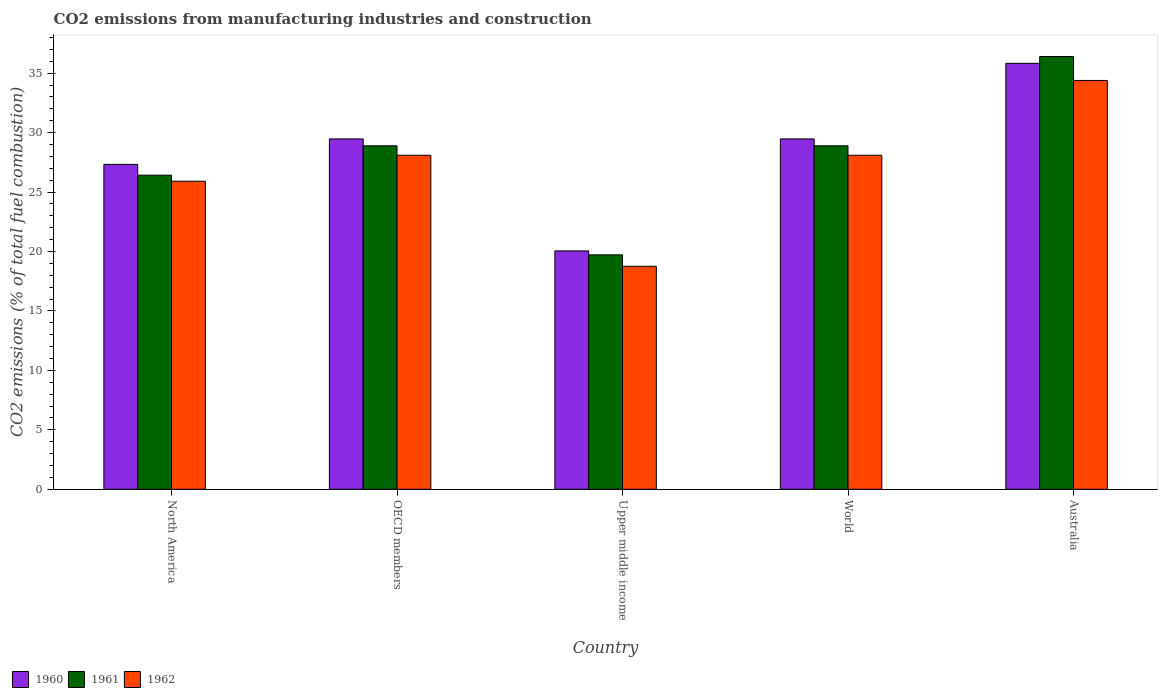How many different coloured bars are there?
Keep it short and to the point. 3. How many bars are there on the 2nd tick from the left?
Keep it short and to the point. 3. How many bars are there on the 2nd tick from the right?
Provide a succinct answer. 3. What is the label of the 3rd group of bars from the left?
Ensure brevity in your answer.  Upper middle income. What is the amount of CO2 emitted in 1961 in World?
Offer a terse response. 28.89. Across all countries, what is the maximum amount of CO2 emitted in 1961?
Your answer should be compact. 36.4. Across all countries, what is the minimum amount of CO2 emitted in 1960?
Your answer should be very brief. 20.05. In which country was the amount of CO2 emitted in 1962 maximum?
Your answer should be very brief. Australia. In which country was the amount of CO2 emitted in 1961 minimum?
Make the answer very short. Upper middle income. What is the total amount of CO2 emitted in 1962 in the graph?
Offer a very short reply. 135.24. What is the difference between the amount of CO2 emitted in 1962 in Upper middle income and that in World?
Provide a succinct answer. -9.34. What is the difference between the amount of CO2 emitted in 1960 in Australia and the amount of CO2 emitted in 1962 in Upper middle income?
Ensure brevity in your answer.  17.07. What is the average amount of CO2 emitted in 1960 per country?
Keep it short and to the point. 28.43. What is the difference between the amount of CO2 emitted of/in 1961 and amount of CO2 emitted of/in 1962 in Upper middle income?
Make the answer very short. 0.96. What is the ratio of the amount of CO2 emitted in 1960 in North America to that in Upper middle income?
Ensure brevity in your answer.  1.36. Is the amount of CO2 emitted in 1960 in OECD members less than that in World?
Ensure brevity in your answer.  No. Is the difference between the amount of CO2 emitted in 1961 in Australia and OECD members greater than the difference between the amount of CO2 emitted in 1962 in Australia and OECD members?
Offer a terse response. Yes. What is the difference between the highest and the second highest amount of CO2 emitted in 1961?
Provide a succinct answer. 7.51. What is the difference between the highest and the lowest amount of CO2 emitted in 1962?
Your response must be concise. 15.63. Are all the bars in the graph horizontal?
Offer a terse response. No. How many countries are there in the graph?
Make the answer very short. 5. Where does the legend appear in the graph?
Provide a short and direct response. Bottom left. What is the title of the graph?
Offer a terse response. CO2 emissions from manufacturing industries and construction. What is the label or title of the Y-axis?
Give a very brief answer. CO2 emissions (% of total fuel combustion). What is the CO2 emissions (% of total fuel combustion) of 1960 in North America?
Give a very brief answer. 27.33. What is the CO2 emissions (% of total fuel combustion) of 1961 in North America?
Your answer should be very brief. 26.42. What is the CO2 emissions (% of total fuel combustion) in 1962 in North America?
Keep it short and to the point. 25.91. What is the CO2 emissions (% of total fuel combustion) of 1960 in OECD members?
Offer a very short reply. 29.47. What is the CO2 emissions (% of total fuel combustion) of 1961 in OECD members?
Your answer should be compact. 28.89. What is the CO2 emissions (% of total fuel combustion) of 1962 in OECD members?
Provide a short and direct response. 28.09. What is the CO2 emissions (% of total fuel combustion) in 1960 in Upper middle income?
Provide a short and direct response. 20.05. What is the CO2 emissions (% of total fuel combustion) of 1961 in Upper middle income?
Keep it short and to the point. 19.72. What is the CO2 emissions (% of total fuel combustion) in 1962 in Upper middle income?
Give a very brief answer. 18.76. What is the CO2 emissions (% of total fuel combustion) of 1960 in World?
Offer a terse response. 29.47. What is the CO2 emissions (% of total fuel combustion) of 1961 in World?
Keep it short and to the point. 28.89. What is the CO2 emissions (% of total fuel combustion) in 1962 in World?
Offer a very short reply. 28.09. What is the CO2 emissions (% of total fuel combustion) of 1960 in Australia?
Your response must be concise. 35.83. What is the CO2 emissions (% of total fuel combustion) of 1961 in Australia?
Keep it short and to the point. 36.4. What is the CO2 emissions (% of total fuel combustion) in 1962 in Australia?
Ensure brevity in your answer.  34.39. Across all countries, what is the maximum CO2 emissions (% of total fuel combustion) in 1960?
Your response must be concise. 35.83. Across all countries, what is the maximum CO2 emissions (% of total fuel combustion) of 1961?
Your answer should be compact. 36.4. Across all countries, what is the maximum CO2 emissions (% of total fuel combustion) of 1962?
Make the answer very short. 34.39. Across all countries, what is the minimum CO2 emissions (% of total fuel combustion) in 1960?
Provide a succinct answer. 20.05. Across all countries, what is the minimum CO2 emissions (% of total fuel combustion) of 1961?
Give a very brief answer. 19.72. Across all countries, what is the minimum CO2 emissions (% of total fuel combustion) in 1962?
Your answer should be compact. 18.76. What is the total CO2 emissions (% of total fuel combustion) in 1960 in the graph?
Offer a very short reply. 142.14. What is the total CO2 emissions (% of total fuel combustion) in 1961 in the graph?
Keep it short and to the point. 140.31. What is the total CO2 emissions (% of total fuel combustion) of 1962 in the graph?
Offer a very short reply. 135.24. What is the difference between the CO2 emissions (% of total fuel combustion) in 1960 in North America and that in OECD members?
Give a very brief answer. -2.14. What is the difference between the CO2 emissions (% of total fuel combustion) in 1961 in North America and that in OECD members?
Provide a succinct answer. -2.47. What is the difference between the CO2 emissions (% of total fuel combustion) of 1962 in North America and that in OECD members?
Offer a terse response. -2.18. What is the difference between the CO2 emissions (% of total fuel combustion) in 1960 in North America and that in Upper middle income?
Your response must be concise. 7.28. What is the difference between the CO2 emissions (% of total fuel combustion) of 1961 in North America and that in Upper middle income?
Offer a very short reply. 6.7. What is the difference between the CO2 emissions (% of total fuel combustion) of 1962 in North America and that in Upper middle income?
Your answer should be very brief. 7.15. What is the difference between the CO2 emissions (% of total fuel combustion) of 1960 in North America and that in World?
Your answer should be very brief. -2.14. What is the difference between the CO2 emissions (% of total fuel combustion) of 1961 in North America and that in World?
Your answer should be very brief. -2.47. What is the difference between the CO2 emissions (% of total fuel combustion) in 1962 in North America and that in World?
Offer a very short reply. -2.18. What is the difference between the CO2 emissions (% of total fuel combustion) in 1960 in North America and that in Australia?
Your answer should be very brief. -8.5. What is the difference between the CO2 emissions (% of total fuel combustion) in 1961 in North America and that in Australia?
Offer a very short reply. -9.98. What is the difference between the CO2 emissions (% of total fuel combustion) of 1962 in North America and that in Australia?
Provide a succinct answer. -8.47. What is the difference between the CO2 emissions (% of total fuel combustion) in 1960 in OECD members and that in Upper middle income?
Keep it short and to the point. 9.42. What is the difference between the CO2 emissions (% of total fuel combustion) of 1961 in OECD members and that in Upper middle income?
Offer a terse response. 9.17. What is the difference between the CO2 emissions (% of total fuel combustion) of 1962 in OECD members and that in Upper middle income?
Offer a terse response. 9.34. What is the difference between the CO2 emissions (% of total fuel combustion) in 1960 in OECD members and that in World?
Make the answer very short. 0. What is the difference between the CO2 emissions (% of total fuel combustion) of 1961 in OECD members and that in World?
Offer a very short reply. 0. What is the difference between the CO2 emissions (% of total fuel combustion) of 1960 in OECD members and that in Australia?
Make the answer very short. -6.36. What is the difference between the CO2 emissions (% of total fuel combustion) in 1961 in OECD members and that in Australia?
Offer a very short reply. -7.51. What is the difference between the CO2 emissions (% of total fuel combustion) of 1962 in OECD members and that in Australia?
Offer a very short reply. -6.29. What is the difference between the CO2 emissions (% of total fuel combustion) of 1960 in Upper middle income and that in World?
Offer a terse response. -9.42. What is the difference between the CO2 emissions (% of total fuel combustion) in 1961 in Upper middle income and that in World?
Your answer should be very brief. -9.17. What is the difference between the CO2 emissions (% of total fuel combustion) of 1962 in Upper middle income and that in World?
Keep it short and to the point. -9.34. What is the difference between the CO2 emissions (% of total fuel combustion) in 1960 in Upper middle income and that in Australia?
Your answer should be compact. -15.78. What is the difference between the CO2 emissions (% of total fuel combustion) in 1961 in Upper middle income and that in Australia?
Provide a succinct answer. -16.68. What is the difference between the CO2 emissions (% of total fuel combustion) in 1962 in Upper middle income and that in Australia?
Your answer should be compact. -15.63. What is the difference between the CO2 emissions (% of total fuel combustion) of 1960 in World and that in Australia?
Ensure brevity in your answer.  -6.36. What is the difference between the CO2 emissions (% of total fuel combustion) in 1961 in World and that in Australia?
Keep it short and to the point. -7.51. What is the difference between the CO2 emissions (% of total fuel combustion) in 1962 in World and that in Australia?
Keep it short and to the point. -6.29. What is the difference between the CO2 emissions (% of total fuel combustion) in 1960 in North America and the CO2 emissions (% of total fuel combustion) in 1961 in OECD members?
Your response must be concise. -1.56. What is the difference between the CO2 emissions (% of total fuel combustion) of 1960 in North America and the CO2 emissions (% of total fuel combustion) of 1962 in OECD members?
Your answer should be very brief. -0.77. What is the difference between the CO2 emissions (% of total fuel combustion) of 1961 in North America and the CO2 emissions (% of total fuel combustion) of 1962 in OECD members?
Your response must be concise. -1.67. What is the difference between the CO2 emissions (% of total fuel combustion) of 1960 in North America and the CO2 emissions (% of total fuel combustion) of 1961 in Upper middle income?
Provide a short and direct response. 7.61. What is the difference between the CO2 emissions (% of total fuel combustion) of 1960 in North America and the CO2 emissions (% of total fuel combustion) of 1962 in Upper middle income?
Keep it short and to the point. 8.57. What is the difference between the CO2 emissions (% of total fuel combustion) in 1961 in North America and the CO2 emissions (% of total fuel combustion) in 1962 in Upper middle income?
Provide a succinct answer. 7.66. What is the difference between the CO2 emissions (% of total fuel combustion) in 1960 in North America and the CO2 emissions (% of total fuel combustion) in 1961 in World?
Ensure brevity in your answer.  -1.56. What is the difference between the CO2 emissions (% of total fuel combustion) of 1960 in North America and the CO2 emissions (% of total fuel combustion) of 1962 in World?
Provide a short and direct response. -0.77. What is the difference between the CO2 emissions (% of total fuel combustion) of 1961 in North America and the CO2 emissions (% of total fuel combustion) of 1962 in World?
Provide a succinct answer. -1.67. What is the difference between the CO2 emissions (% of total fuel combustion) of 1960 in North America and the CO2 emissions (% of total fuel combustion) of 1961 in Australia?
Your answer should be very brief. -9.07. What is the difference between the CO2 emissions (% of total fuel combustion) in 1960 in North America and the CO2 emissions (% of total fuel combustion) in 1962 in Australia?
Your answer should be compact. -7.06. What is the difference between the CO2 emissions (% of total fuel combustion) of 1961 in North America and the CO2 emissions (% of total fuel combustion) of 1962 in Australia?
Provide a succinct answer. -7.97. What is the difference between the CO2 emissions (% of total fuel combustion) in 1960 in OECD members and the CO2 emissions (% of total fuel combustion) in 1961 in Upper middle income?
Keep it short and to the point. 9.75. What is the difference between the CO2 emissions (% of total fuel combustion) of 1960 in OECD members and the CO2 emissions (% of total fuel combustion) of 1962 in Upper middle income?
Keep it short and to the point. 10.71. What is the difference between the CO2 emissions (% of total fuel combustion) of 1961 in OECD members and the CO2 emissions (% of total fuel combustion) of 1962 in Upper middle income?
Your answer should be compact. 10.13. What is the difference between the CO2 emissions (% of total fuel combustion) in 1960 in OECD members and the CO2 emissions (% of total fuel combustion) in 1961 in World?
Offer a terse response. 0.58. What is the difference between the CO2 emissions (% of total fuel combustion) in 1960 in OECD members and the CO2 emissions (% of total fuel combustion) in 1962 in World?
Offer a very short reply. 1.38. What is the difference between the CO2 emissions (% of total fuel combustion) in 1961 in OECD members and the CO2 emissions (% of total fuel combustion) in 1962 in World?
Provide a succinct answer. 0.79. What is the difference between the CO2 emissions (% of total fuel combustion) in 1960 in OECD members and the CO2 emissions (% of total fuel combustion) in 1961 in Australia?
Keep it short and to the point. -6.93. What is the difference between the CO2 emissions (% of total fuel combustion) of 1960 in OECD members and the CO2 emissions (% of total fuel combustion) of 1962 in Australia?
Ensure brevity in your answer.  -4.92. What is the difference between the CO2 emissions (% of total fuel combustion) of 1961 in OECD members and the CO2 emissions (% of total fuel combustion) of 1962 in Australia?
Ensure brevity in your answer.  -5.5. What is the difference between the CO2 emissions (% of total fuel combustion) in 1960 in Upper middle income and the CO2 emissions (% of total fuel combustion) in 1961 in World?
Your answer should be compact. -8.84. What is the difference between the CO2 emissions (% of total fuel combustion) of 1960 in Upper middle income and the CO2 emissions (% of total fuel combustion) of 1962 in World?
Provide a succinct answer. -8.04. What is the difference between the CO2 emissions (% of total fuel combustion) of 1961 in Upper middle income and the CO2 emissions (% of total fuel combustion) of 1962 in World?
Offer a very short reply. -8.38. What is the difference between the CO2 emissions (% of total fuel combustion) of 1960 in Upper middle income and the CO2 emissions (% of total fuel combustion) of 1961 in Australia?
Provide a short and direct response. -16.35. What is the difference between the CO2 emissions (% of total fuel combustion) of 1960 in Upper middle income and the CO2 emissions (% of total fuel combustion) of 1962 in Australia?
Make the answer very short. -14.34. What is the difference between the CO2 emissions (% of total fuel combustion) of 1961 in Upper middle income and the CO2 emissions (% of total fuel combustion) of 1962 in Australia?
Your answer should be very brief. -14.67. What is the difference between the CO2 emissions (% of total fuel combustion) in 1960 in World and the CO2 emissions (% of total fuel combustion) in 1961 in Australia?
Offer a terse response. -6.93. What is the difference between the CO2 emissions (% of total fuel combustion) of 1960 in World and the CO2 emissions (% of total fuel combustion) of 1962 in Australia?
Offer a terse response. -4.92. What is the difference between the CO2 emissions (% of total fuel combustion) of 1961 in World and the CO2 emissions (% of total fuel combustion) of 1962 in Australia?
Provide a short and direct response. -5.5. What is the average CO2 emissions (% of total fuel combustion) in 1960 per country?
Your answer should be very brief. 28.43. What is the average CO2 emissions (% of total fuel combustion) of 1961 per country?
Your answer should be compact. 28.06. What is the average CO2 emissions (% of total fuel combustion) of 1962 per country?
Your response must be concise. 27.05. What is the difference between the CO2 emissions (% of total fuel combustion) in 1960 and CO2 emissions (% of total fuel combustion) in 1961 in North America?
Offer a terse response. 0.91. What is the difference between the CO2 emissions (% of total fuel combustion) in 1960 and CO2 emissions (% of total fuel combustion) in 1962 in North America?
Ensure brevity in your answer.  1.42. What is the difference between the CO2 emissions (% of total fuel combustion) in 1961 and CO2 emissions (% of total fuel combustion) in 1962 in North America?
Keep it short and to the point. 0.51. What is the difference between the CO2 emissions (% of total fuel combustion) in 1960 and CO2 emissions (% of total fuel combustion) in 1961 in OECD members?
Provide a succinct answer. 0.58. What is the difference between the CO2 emissions (% of total fuel combustion) in 1960 and CO2 emissions (% of total fuel combustion) in 1962 in OECD members?
Keep it short and to the point. 1.38. What is the difference between the CO2 emissions (% of total fuel combustion) of 1961 and CO2 emissions (% of total fuel combustion) of 1962 in OECD members?
Provide a succinct answer. 0.79. What is the difference between the CO2 emissions (% of total fuel combustion) of 1960 and CO2 emissions (% of total fuel combustion) of 1961 in Upper middle income?
Keep it short and to the point. 0.33. What is the difference between the CO2 emissions (% of total fuel combustion) in 1960 and CO2 emissions (% of total fuel combustion) in 1962 in Upper middle income?
Your answer should be compact. 1.29. What is the difference between the CO2 emissions (% of total fuel combustion) of 1961 and CO2 emissions (% of total fuel combustion) of 1962 in Upper middle income?
Ensure brevity in your answer.  0.96. What is the difference between the CO2 emissions (% of total fuel combustion) of 1960 and CO2 emissions (% of total fuel combustion) of 1961 in World?
Ensure brevity in your answer.  0.58. What is the difference between the CO2 emissions (% of total fuel combustion) of 1960 and CO2 emissions (% of total fuel combustion) of 1962 in World?
Ensure brevity in your answer.  1.38. What is the difference between the CO2 emissions (% of total fuel combustion) in 1961 and CO2 emissions (% of total fuel combustion) in 1962 in World?
Make the answer very short. 0.79. What is the difference between the CO2 emissions (% of total fuel combustion) of 1960 and CO2 emissions (% of total fuel combustion) of 1961 in Australia?
Provide a succinct answer. -0.57. What is the difference between the CO2 emissions (% of total fuel combustion) in 1960 and CO2 emissions (% of total fuel combustion) in 1962 in Australia?
Your response must be concise. 1.44. What is the difference between the CO2 emissions (% of total fuel combustion) in 1961 and CO2 emissions (% of total fuel combustion) in 1962 in Australia?
Keep it short and to the point. 2.01. What is the ratio of the CO2 emissions (% of total fuel combustion) in 1960 in North America to that in OECD members?
Your answer should be compact. 0.93. What is the ratio of the CO2 emissions (% of total fuel combustion) of 1961 in North America to that in OECD members?
Keep it short and to the point. 0.91. What is the ratio of the CO2 emissions (% of total fuel combustion) of 1962 in North America to that in OECD members?
Your answer should be compact. 0.92. What is the ratio of the CO2 emissions (% of total fuel combustion) in 1960 in North America to that in Upper middle income?
Your response must be concise. 1.36. What is the ratio of the CO2 emissions (% of total fuel combustion) in 1961 in North America to that in Upper middle income?
Make the answer very short. 1.34. What is the ratio of the CO2 emissions (% of total fuel combustion) of 1962 in North America to that in Upper middle income?
Keep it short and to the point. 1.38. What is the ratio of the CO2 emissions (% of total fuel combustion) in 1960 in North America to that in World?
Make the answer very short. 0.93. What is the ratio of the CO2 emissions (% of total fuel combustion) in 1961 in North America to that in World?
Give a very brief answer. 0.91. What is the ratio of the CO2 emissions (% of total fuel combustion) of 1962 in North America to that in World?
Make the answer very short. 0.92. What is the ratio of the CO2 emissions (% of total fuel combustion) of 1960 in North America to that in Australia?
Provide a short and direct response. 0.76. What is the ratio of the CO2 emissions (% of total fuel combustion) of 1961 in North America to that in Australia?
Provide a short and direct response. 0.73. What is the ratio of the CO2 emissions (% of total fuel combustion) of 1962 in North America to that in Australia?
Offer a terse response. 0.75. What is the ratio of the CO2 emissions (% of total fuel combustion) in 1960 in OECD members to that in Upper middle income?
Provide a short and direct response. 1.47. What is the ratio of the CO2 emissions (% of total fuel combustion) of 1961 in OECD members to that in Upper middle income?
Provide a short and direct response. 1.47. What is the ratio of the CO2 emissions (% of total fuel combustion) of 1962 in OECD members to that in Upper middle income?
Give a very brief answer. 1.5. What is the ratio of the CO2 emissions (% of total fuel combustion) of 1960 in OECD members to that in World?
Keep it short and to the point. 1. What is the ratio of the CO2 emissions (% of total fuel combustion) of 1961 in OECD members to that in World?
Provide a succinct answer. 1. What is the ratio of the CO2 emissions (% of total fuel combustion) in 1962 in OECD members to that in World?
Make the answer very short. 1. What is the ratio of the CO2 emissions (% of total fuel combustion) of 1960 in OECD members to that in Australia?
Your answer should be compact. 0.82. What is the ratio of the CO2 emissions (% of total fuel combustion) of 1961 in OECD members to that in Australia?
Offer a terse response. 0.79. What is the ratio of the CO2 emissions (% of total fuel combustion) of 1962 in OECD members to that in Australia?
Offer a terse response. 0.82. What is the ratio of the CO2 emissions (% of total fuel combustion) of 1960 in Upper middle income to that in World?
Give a very brief answer. 0.68. What is the ratio of the CO2 emissions (% of total fuel combustion) in 1961 in Upper middle income to that in World?
Offer a very short reply. 0.68. What is the ratio of the CO2 emissions (% of total fuel combustion) of 1962 in Upper middle income to that in World?
Provide a short and direct response. 0.67. What is the ratio of the CO2 emissions (% of total fuel combustion) in 1960 in Upper middle income to that in Australia?
Your response must be concise. 0.56. What is the ratio of the CO2 emissions (% of total fuel combustion) in 1961 in Upper middle income to that in Australia?
Make the answer very short. 0.54. What is the ratio of the CO2 emissions (% of total fuel combustion) of 1962 in Upper middle income to that in Australia?
Keep it short and to the point. 0.55. What is the ratio of the CO2 emissions (% of total fuel combustion) in 1960 in World to that in Australia?
Offer a terse response. 0.82. What is the ratio of the CO2 emissions (% of total fuel combustion) in 1961 in World to that in Australia?
Make the answer very short. 0.79. What is the ratio of the CO2 emissions (% of total fuel combustion) in 1962 in World to that in Australia?
Provide a succinct answer. 0.82. What is the difference between the highest and the second highest CO2 emissions (% of total fuel combustion) in 1960?
Offer a terse response. 6.36. What is the difference between the highest and the second highest CO2 emissions (% of total fuel combustion) of 1961?
Your answer should be very brief. 7.51. What is the difference between the highest and the second highest CO2 emissions (% of total fuel combustion) in 1962?
Ensure brevity in your answer.  6.29. What is the difference between the highest and the lowest CO2 emissions (% of total fuel combustion) in 1960?
Provide a succinct answer. 15.78. What is the difference between the highest and the lowest CO2 emissions (% of total fuel combustion) of 1961?
Offer a very short reply. 16.68. What is the difference between the highest and the lowest CO2 emissions (% of total fuel combustion) of 1962?
Offer a terse response. 15.63. 